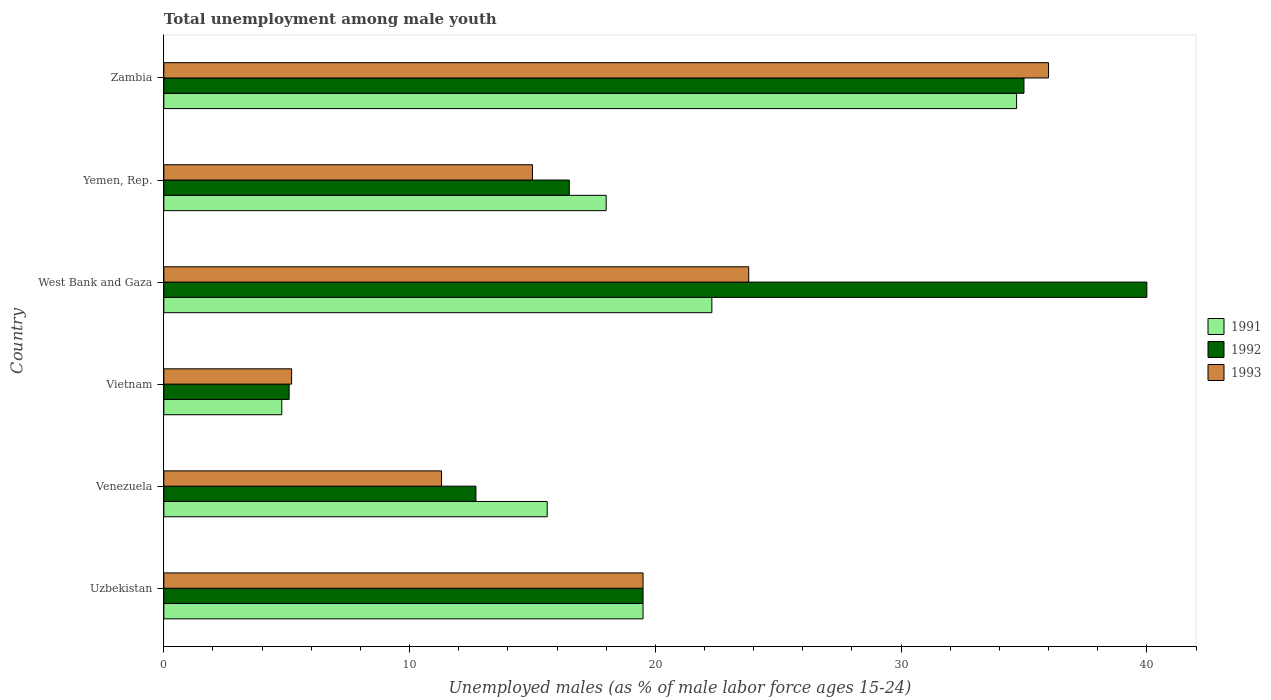Are the number of bars per tick equal to the number of legend labels?
Your answer should be very brief. Yes. Are the number of bars on each tick of the Y-axis equal?
Keep it short and to the point. Yes. How many bars are there on the 2nd tick from the top?
Keep it short and to the point. 3. What is the label of the 4th group of bars from the top?
Offer a very short reply. Vietnam. Across all countries, what is the maximum percentage of unemployed males in in 1991?
Your answer should be very brief. 34.7. Across all countries, what is the minimum percentage of unemployed males in in 1992?
Keep it short and to the point. 5.1. In which country was the percentage of unemployed males in in 1991 maximum?
Your answer should be very brief. Zambia. In which country was the percentage of unemployed males in in 1991 minimum?
Provide a short and direct response. Vietnam. What is the total percentage of unemployed males in in 1992 in the graph?
Offer a terse response. 128.8. What is the difference between the percentage of unemployed males in in 1991 in Uzbekistan and that in Zambia?
Offer a very short reply. -15.2. What is the difference between the percentage of unemployed males in in 1991 in Yemen, Rep. and the percentage of unemployed males in in 1993 in Uzbekistan?
Your answer should be compact. -1.5. What is the average percentage of unemployed males in in 1993 per country?
Offer a very short reply. 18.47. What is the ratio of the percentage of unemployed males in in 1991 in West Bank and Gaza to that in Zambia?
Keep it short and to the point. 0.64. Is the percentage of unemployed males in in 1991 in Venezuela less than that in West Bank and Gaza?
Give a very brief answer. Yes. What is the difference between the highest and the second highest percentage of unemployed males in in 1993?
Provide a succinct answer. 12.2. What is the difference between the highest and the lowest percentage of unemployed males in in 1993?
Provide a succinct answer. 30.8. In how many countries, is the percentage of unemployed males in in 1991 greater than the average percentage of unemployed males in in 1991 taken over all countries?
Make the answer very short. 3. What does the 3rd bar from the top in Yemen, Rep. represents?
Your response must be concise. 1991. How many countries are there in the graph?
Provide a succinct answer. 6. What is the difference between two consecutive major ticks on the X-axis?
Ensure brevity in your answer.  10. Does the graph contain any zero values?
Your response must be concise. No. Where does the legend appear in the graph?
Offer a terse response. Center right. What is the title of the graph?
Keep it short and to the point. Total unemployment among male youth. What is the label or title of the X-axis?
Provide a short and direct response. Unemployed males (as % of male labor force ages 15-24). What is the Unemployed males (as % of male labor force ages 15-24) of 1993 in Uzbekistan?
Your answer should be very brief. 19.5. What is the Unemployed males (as % of male labor force ages 15-24) in 1991 in Venezuela?
Provide a succinct answer. 15.6. What is the Unemployed males (as % of male labor force ages 15-24) of 1992 in Venezuela?
Keep it short and to the point. 12.7. What is the Unemployed males (as % of male labor force ages 15-24) in 1993 in Venezuela?
Give a very brief answer. 11.3. What is the Unemployed males (as % of male labor force ages 15-24) in 1991 in Vietnam?
Give a very brief answer. 4.8. What is the Unemployed males (as % of male labor force ages 15-24) of 1992 in Vietnam?
Keep it short and to the point. 5.1. What is the Unemployed males (as % of male labor force ages 15-24) in 1993 in Vietnam?
Provide a succinct answer. 5.2. What is the Unemployed males (as % of male labor force ages 15-24) in 1991 in West Bank and Gaza?
Provide a short and direct response. 22.3. What is the Unemployed males (as % of male labor force ages 15-24) of 1993 in West Bank and Gaza?
Provide a short and direct response. 23.8. What is the Unemployed males (as % of male labor force ages 15-24) of 1991 in Zambia?
Give a very brief answer. 34.7. What is the Unemployed males (as % of male labor force ages 15-24) of 1993 in Zambia?
Offer a very short reply. 36. Across all countries, what is the maximum Unemployed males (as % of male labor force ages 15-24) of 1991?
Offer a very short reply. 34.7. Across all countries, what is the maximum Unemployed males (as % of male labor force ages 15-24) in 1992?
Your answer should be very brief. 40. Across all countries, what is the minimum Unemployed males (as % of male labor force ages 15-24) of 1991?
Your response must be concise. 4.8. Across all countries, what is the minimum Unemployed males (as % of male labor force ages 15-24) in 1992?
Your answer should be very brief. 5.1. Across all countries, what is the minimum Unemployed males (as % of male labor force ages 15-24) in 1993?
Provide a short and direct response. 5.2. What is the total Unemployed males (as % of male labor force ages 15-24) of 1991 in the graph?
Your response must be concise. 114.9. What is the total Unemployed males (as % of male labor force ages 15-24) of 1992 in the graph?
Keep it short and to the point. 128.8. What is the total Unemployed males (as % of male labor force ages 15-24) of 1993 in the graph?
Make the answer very short. 110.8. What is the difference between the Unemployed males (as % of male labor force ages 15-24) of 1991 in Uzbekistan and that in Venezuela?
Give a very brief answer. 3.9. What is the difference between the Unemployed males (as % of male labor force ages 15-24) of 1992 in Uzbekistan and that in Venezuela?
Offer a terse response. 6.8. What is the difference between the Unemployed males (as % of male labor force ages 15-24) in 1991 in Uzbekistan and that in Vietnam?
Offer a terse response. 14.7. What is the difference between the Unemployed males (as % of male labor force ages 15-24) in 1993 in Uzbekistan and that in Vietnam?
Ensure brevity in your answer.  14.3. What is the difference between the Unemployed males (as % of male labor force ages 15-24) of 1992 in Uzbekistan and that in West Bank and Gaza?
Ensure brevity in your answer.  -20.5. What is the difference between the Unemployed males (as % of male labor force ages 15-24) of 1993 in Uzbekistan and that in West Bank and Gaza?
Your answer should be compact. -4.3. What is the difference between the Unemployed males (as % of male labor force ages 15-24) of 1991 in Uzbekistan and that in Yemen, Rep.?
Give a very brief answer. 1.5. What is the difference between the Unemployed males (as % of male labor force ages 15-24) in 1992 in Uzbekistan and that in Yemen, Rep.?
Provide a short and direct response. 3. What is the difference between the Unemployed males (as % of male labor force ages 15-24) of 1993 in Uzbekistan and that in Yemen, Rep.?
Make the answer very short. 4.5. What is the difference between the Unemployed males (as % of male labor force ages 15-24) in 1991 in Uzbekistan and that in Zambia?
Provide a short and direct response. -15.2. What is the difference between the Unemployed males (as % of male labor force ages 15-24) in 1992 in Uzbekistan and that in Zambia?
Your answer should be compact. -15.5. What is the difference between the Unemployed males (as % of male labor force ages 15-24) of 1993 in Uzbekistan and that in Zambia?
Offer a very short reply. -16.5. What is the difference between the Unemployed males (as % of male labor force ages 15-24) in 1992 in Venezuela and that in Vietnam?
Your response must be concise. 7.6. What is the difference between the Unemployed males (as % of male labor force ages 15-24) in 1991 in Venezuela and that in West Bank and Gaza?
Your answer should be compact. -6.7. What is the difference between the Unemployed males (as % of male labor force ages 15-24) in 1992 in Venezuela and that in West Bank and Gaza?
Offer a terse response. -27.3. What is the difference between the Unemployed males (as % of male labor force ages 15-24) of 1992 in Venezuela and that in Yemen, Rep.?
Make the answer very short. -3.8. What is the difference between the Unemployed males (as % of male labor force ages 15-24) of 1991 in Venezuela and that in Zambia?
Your response must be concise. -19.1. What is the difference between the Unemployed males (as % of male labor force ages 15-24) in 1992 in Venezuela and that in Zambia?
Ensure brevity in your answer.  -22.3. What is the difference between the Unemployed males (as % of male labor force ages 15-24) in 1993 in Venezuela and that in Zambia?
Ensure brevity in your answer.  -24.7. What is the difference between the Unemployed males (as % of male labor force ages 15-24) in 1991 in Vietnam and that in West Bank and Gaza?
Ensure brevity in your answer.  -17.5. What is the difference between the Unemployed males (as % of male labor force ages 15-24) in 1992 in Vietnam and that in West Bank and Gaza?
Make the answer very short. -34.9. What is the difference between the Unemployed males (as % of male labor force ages 15-24) of 1993 in Vietnam and that in West Bank and Gaza?
Keep it short and to the point. -18.6. What is the difference between the Unemployed males (as % of male labor force ages 15-24) of 1993 in Vietnam and that in Yemen, Rep.?
Offer a terse response. -9.8. What is the difference between the Unemployed males (as % of male labor force ages 15-24) of 1991 in Vietnam and that in Zambia?
Provide a succinct answer. -29.9. What is the difference between the Unemployed males (as % of male labor force ages 15-24) of 1992 in Vietnam and that in Zambia?
Provide a short and direct response. -29.9. What is the difference between the Unemployed males (as % of male labor force ages 15-24) in 1993 in Vietnam and that in Zambia?
Your answer should be compact. -30.8. What is the difference between the Unemployed males (as % of male labor force ages 15-24) in 1991 in West Bank and Gaza and that in Yemen, Rep.?
Give a very brief answer. 4.3. What is the difference between the Unemployed males (as % of male labor force ages 15-24) in 1992 in West Bank and Gaza and that in Yemen, Rep.?
Provide a short and direct response. 23.5. What is the difference between the Unemployed males (as % of male labor force ages 15-24) of 1992 in West Bank and Gaza and that in Zambia?
Give a very brief answer. 5. What is the difference between the Unemployed males (as % of male labor force ages 15-24) in 1991 in Yemen, Rep. and that in Zambia?
Your answer should be compact. -16.7. What is the difference between the Unemployed males (as % of male labor force ages 15-24) in 1992 in Yemen, Rep. and that in Zambia?
Ensure brevity in your answer.  -18.5. What is the difference between the Unemployed males (as % of male labor force ages 15-24) in 1993 in Yemen, Rep. and that in Zambia?
Offer a very short reply. -21. What is the difference between the Unemployed males (as % of male labor force ages 15-24) of 1992 in Uzbekistan and the Unemployed males (as % of male labor force ages 15-24) of 1993 in Venezuela?
Keep it short and to the point. 8.2. What is the difference between the Unemployed males (as % of male labor force ages 15-24) in 1991 in Uzbekistan and the Unemployed males (as % of male labor force ages 15-24) in 1992 in Vietnam?
Your answer should be very brief. 14.4. What is the difference between the Unemployed males (as % of male labor force ages 15-24) of 1991 in Uzbekistan and the Unemployed males (as % of male labor force ages 15-24) of 1993 in Vietnam?
Provide a short and direct response. 14.3. What is the difference between the Unemployed males (as % of male labor force ages 15-24) in 1991 in Uzbekistan and the Unemployed males (as % of male labor force ages 15-24) in 1992 in West Bank and Gaza?
Your answer should be very brief. -20.5. What is the difference between the Unemployed males (as % of male labor force ages 15-24) in 1991 in Uzbekistan and the Unemployed males (as % of male labor force ages 15-24) in 1992 in Zambia?
Give a very brief answer. -15.5. What is the difference between the Unemployed males (as % of male labor force ages 15-24) in 1991 in Uzbekistan and the Unemployed males (as % of male labor force ages 15-24) in 1993 in Zambia?
Make the answer very short. -16.5. What is the difference between the Unemployed males (as % of male labor force ages 15-24) of 1992 in Uzbekistan and the Unemployed males (as % of male labor force ages 15-24) of 1993 in Zambia?
Provide a succinct answer. -16.5. What is the difference between the Unemployed males (as % of male labor force ages 15-24) of 1991 in Venezuela and the Unemployed males (as % of male labor force ages 15-24) of 1992 in West Bank and Gaza?
Your answer should be compact. -24.4. What is the difference between the Unemployed males (as % of male labor force ages 15-24) of 1992 in Venezuela and the Unemployed males (as % of male labor force ages 15-24) of 1993 in West Bank and Gaza?
Your response must be concise. -11.1. What is the difference between the Unemployed males (as % of male labor force ages 15-24) of 1991 in Venezuela and the Unemployed males (as % of male labor force ages 15-24) of 1992 in Zambia?
Ensure brevity in your answer.  -19.4. What is the difference between the Unemployed males (as % of male labor force ages 15-24) in 1991 in Venezuela and the Unemployed males (as % of male labor force ages 15-24) in 1993 in Zambia?
Make the answer very short. -20.4. What is the difference between the Unemployed males (as % of male labor force ages 15-24) in 1992 in Venezuela and the Unemployed males (as % of male labor force ages 15-24) in 1993 in Zambia?
Ensure brevity in your answer.  -23.3. What is the difference between the Unemployed males (as % of male labor force ages 15-24) in 1991 in Vietnam and the Unemployed males (as % of male labor force ages 15-24) in 1992 in West Bank and Gaza?
Give a very brief answer. -35.2. What is the difference between the Unemployed males (as % of male labor force ages 15-24) of 1991 in Vietnam and the Unemployed males (as % of male labor force ages 15-24) of 1993 in West Bank and Gaza?
Your answer should be very brief. -19. What is the difference between the Unemployed males (as % of male labor force ages 15-24) of 1992 in Vietnam and the Unemployed males (as % of male labor force ages 15-24) of 1993 in West Bank and Gaza?
Provide a short and direct response. -18.7. What is the difference between the Unemployed males (as % of male labor force ages 15-24) in 1991 in Vietnam and the Unemployed males (as % of male labor force ages 15-24) in 1992 in Zambia?
Provide a short and direct response. -30.2. What is the difference between the Unemployed males (as % of male labor force ages 15-24) in 1991 in Vietnam and the Unemployed males (as % of male labor force ages 15-24) in 1993 in Zambia?
Provide a short and direct response. -31.2. What is the difference between the Unemployed males (as % of male labor force ages 15-24) in 1992 in Vietnam and the Unemployed males (as % of male labor force ages 15-24) in 1993 in Zambia?
Provide a succinct answer. -30.9. What is the difference between the Unemployed males (as % of male labor force ages 15-24) of 1992 in West Bank and Gaza and the Unemployed males (as % of male labor force ages 15-24) of 1993 in Yemen, Rep.?
Provide a succinct answer. 25. What is the difference between the Unemployed males (as % of male labor force ages 15-24) of 1991 in West Bank and Gaza and the Unemployed males (as % of male labor force ages 15-24) of 1992 in Zambia?
Keep it short and to the point. -12.7. What is the difference between the Unemployed males (as % of male labor force ages 15-24) of 1991 in West Bank and Gaza and the Unemployed males (as % of male labor force ages 15-24) of 1993 in Zambia?
Ensure brevity in your answer.  -13.7. What is the difference between the Unemployed males (as % of male labor force ages 15-24) of 1992 in Yemen, Rep. and the Unemployed males (as % of male labor force ages 15-24) of 1993 in Zambia?
Your answer should be very brief. -19.5. What is the average Unemployed males (as % of male labor force ages 15-24) of 1991 per country?
Provide a short and direct response. 19.15. What is the average Unemployed males (as % of male labor force ages 15-24) in 1992 per country?
Provide a short and direct response. 21.47. What is the average Unemployed males (as % of male labor force ages 15-24) in 1993 per country?
Your response must be concise. 18.47. What is the difference between the Unemployed males (as % of male labor force ages 15-24) in 1991 and Unemployed males (as % of male labor force ages 15-24) in 1993 in Uzbekistan?
Make the answer very short. 0. What is the difference between the Unemployed males (as % of male labor force ages 15-24) of 1991 and Unemployed males (as % of male labor force ages 15-24) of 1992 in Vietnam?
Your response must be concise. -0.3. What is the difference between the Unemployed males (as % of male labor force ages 15-24) of 1992 and Unemployed males (as % of male labor force ages 15-24) of 1993 in Vietnam?
Provide a succinct answer. -0.1. What is the difference between the Unemployed males (as % of male labor force ages 15-24) in 1991 and Unemployed males (as % of male labor force ages 15-24) in 1992 in West Bank and Gaza?
Make the answer very short. -17.7. What is the difference between the Unemployed males (as % of male labor force ages 15-24) of 1991 and Unemployed males (as % of male labor force ages 15-24) of 1993 in Yemen, Rep.?
Ensure brevity in your answer.  3. What is the ratio of the Unemployed males (as % of male labor force ages 15-24) in 1991 in Uzbekistan to that in Venezuela?
Offer a very short reply. 1.25. What is the ratio of the Unemployed males (as % of male labor force ages 15-24) in 1992 in Uzbekistan to that in Venezuela?
Provide a short and direct response. 1.54. What is the ratio of the Unemployed males (as % of male labor force ages 15-24) in 1993 in Uzbekistan to that in Venezuela?
Make the answer very short. 1.73. What is the ratio of the Unemployed males (as % of male labor force ages 15-24) of 1991 in Uzbekistan to that in Vietnam?
Ensure brevity in your answer.  4.06. What is the ratio of the Unemployed males (as % of male labor force ages 15-24) of 1992 in Uzbekistan to that in Vietnam?
Your response must be concise. 3.82. What is the ratio of the Unemployed males (as % of male labor force ages 15-24) of 1993 in Uzbekistan to that in Vietnam?
Your answer should be compact. 3.75. What is the ratio of the Unemployed males (as % of male labor force ages 15-24) in 1991 in Uzbekistan to that in West Bank and Gaza?
Your answer should be very brief. 0.87. What is the ratio of the Unemployed males (as % of male labor force ages 15-24) in 1992 in Uzbekistan to that in West Bank and Gaza?
Keep it short and to the point. 0.49. What is the ratio of the Unemployed males (as % of male labor force ages 15-24) of 1993 in Uzbekistan to that in West Bank and Gaza?
Your answer should be compact. 0.82. What is the ratio of the Unemployed males (as % of male labor force ages 15-24) in 1992 in Uzbekistan to that in Yemen, Rep.?
Give a very brief answer. 1.18. What is the ratio of the Unemployed males (as % of male labor force ages 15-24) in 1993 in Uzbekistan to that in Yemen, Rep.?
Provide a succinct answer. 1.3. What is the ratio of the Unemployed males (as % of male labor force ages 15-24) in 1991 in Uzbekistan to that in Zambia?
Your answer should be very brief. 0.56. What is the ratio of the Unemployed males (as % of male labor force ages 15-24) of 1992 in Uzbekistan to that in Zambia?
Provide a succinct answer. 0.56. What is the ratio of the Unemployed males (as % of male labor force ages 15-24) in 1993 in Uzbekistan to that in Zambia?
Your answer should be compact. 0.54. What is the ratio of the Unemployed males (as % of male labor force ages 15-24) of 1991 in Venezuela to that in Vietnam?
Your answer should be very brief. 3.25. What is the ratio of the Unemployed males (as % of male labor force ages 15-24) in 1992 in Venezuela to that in Vietnam?
Ensure brevity in your answer.  2.49. What is the ratio of the Unemployed males (as % of male labor force ages 15-24) of 1993 in Venezuela to that in Vietnam?
Keep it short and to the point. 2.17. What is the ratio of the Unemployed males (as % of male labor force ages 15-24) in 1991 in Venezuela to that in West Bank and Gaza?
Your answer should be compact. 0.7. What is the ratio of the Unemployed males (as % of male labor force ages 15-24) of 1992 in Venezuela to that in West Bank and Gaza?
Provide a short and direct response. 0.32. What is the ratio of the Unemployed males (as % of male labor force ages 15-24) in 1993 in Venezuela to that in West Bank and Gaza?
Your response must be concise. 0.47. What is the ratio of the Unemployed males (as % of male labor force ages 15-24) in 1991 in Venezuela to that in Yemen, Rep.?
Keep it short and to the point. 0.87. What is the ratio of the Unemployed males (as % of male labor force ages 15-24) of 1992 in Venezuela to that in Yemen, Rep.?
Make the answer very short. 0.77. What is the ratio of the Unemployed males (as % of male labor force ages 15-24) in 1993 in Venezuela to that in Yemen, Rep.?
Make the answer very short. 0.75. What is the ratio of the Unemployed males (as % of male labor force ages 15-24) of 1991 in Venezuela to that in Zambia?
Make the answer very short. 0.45. What is the ratio of the Unemployed males (as % of male labor force ages 15-24) in 1992 in Venezuela to that in Zambia?
Give a very brief answer. 0.36. What is the ratio of the Unemployed males (as % of male labor force ages 15-24) in 1993 in Venezuela to that in Zambia?
Provide a succinct answer. 0.31. What is the ratio of the Unemployed males (as % of male labor force ages 15-24) of 1991 in Vietnam to that in West Bank and Gaza?
Your response must be concise. 0.22. What is the ratio of the Unemployed males (as % of male labor force ages 15-24) in 1992 in Vietnam to that in West Bank and Gaza?
Your answer should be very brief. 0.13. What is the ratio of the Unemployed males (as % of male labor force ages 15-24) of 1993 in Vietnam to that in West Bank and Gaza?
Provide a succinct answer. 0.22. What is the ratio of the Unemployed males (as % of male labor force ages 15-24) in 1991 in Vietnam to that in Yemen, Rep.?
Offer a terse response. 0.27. What is the ratio of the Unemployed males (as % of male labor force ages 15-24) of 1992 in Vietnam to that in Yemen, Rep.?
Provide a short and direct response. 0.31. What is the ratio of the Unemployed males (as % of male labor force ages 15-24) of 1993 in Vietnam to that in Yemen, Rep.?
Make the answer very short. 0.35. What is the ratio of the Unemployed males (as % of male labor force ages 15-24) in 1991 in Vietnam to that in Zambia?
Offer a very short reply. 0.14. What is the ratio of the Unemployed males (as % of male labor force ages 15-24) in 1992 in Vietnam to that in Zambia?
Give a very brief answer. 0.15. What is the ratio of the Unemployed males (as % of male labor force ages 15-24) of 1993 in Vietnam to that in Zambia?
Give a very brief answer. 0.14. What is the ratio of the Unemployed males (as % of male labor force ages 15-24) of 1991 in West Bank and Gaza to that in Yemen, Rep.?
Make the answer very short. 1.24. What is the ratio of the Unemployed males (as % of male labor force ages 15-24) of 1992 in West Bank and Gaza to that in Yemen, Rep.?
Make the answer very short. 2.42. What is the ratio of the Unemployed males (as % of male labor force ages 15-24) in 1993 in West Bank and Gaza to that in Yemen, Rep.?
Provide a short and direct response. 1.59. What is the ratio of the Unemployed males (as % of male labor force ages 15-24) of 1991 in West Bank and Gaza to that in Zambia?
Your answer should be very brief. 0.64. What is the ratio of the Unemployed males (as % of male labor force ages 15-24) in 1993 in West Bank and Gaza to that in Zambia?
Your response must be concise. 0.66. What is the ratio of the Unemployed males (as % of male labor force ages 15-24) of 1991 in Yemen, Rep. to that in Zambia?
Offer a very short reply. 0.52. What is the ratio of the Unemployed males (as % of male labor force ages 15-24) of 1992 in Yemen, Rep. to that in Zambia?
Keep it short and to the point. 0.47. What is the ratio of the Unemployed males (as % of male labor force ages 15-24) in 1993 in Yemen, Rep. to that in Zambia?
Give a very brief answer. 0.42. What is the difference between the highest and the second highest Unemployed males (as % of male labor force ages 15-24) of 1991?
Make the answer very short. 12.4. What is the difference between the highest and the second highest Unemployed males (as % of male labor force ages 15-24) of 1993?
Offer a terse response. 12.2. What is the difference between the highest and the lowest Unemployed males (as % of male labor force ages 15-24) in 1991?
Your answer should be very brief. 29.9. What is the difference between the highest and the lowest Unemployed males (as % of male labor force ages 15-24) of 1992?
Provide a succinct answer. 34.9. What is the difference between the highest and the lowest Unemployed males (as % of male labor force ages 15-24) in 1993?
Your answer should be very brief. 30.8. 